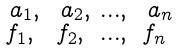Convert formula to latex. <formula><loc_0><loc_0><loc_500><loc_500>\begin{smallmatrix} \ a _ { 1 } , & \ a _ { 2 } , & \dots , & \ a _ { n } \\ f _ { 1 } , & f _ { 2 } , & \dots , & f _ { n } \end{smallmatrix}</formula> 